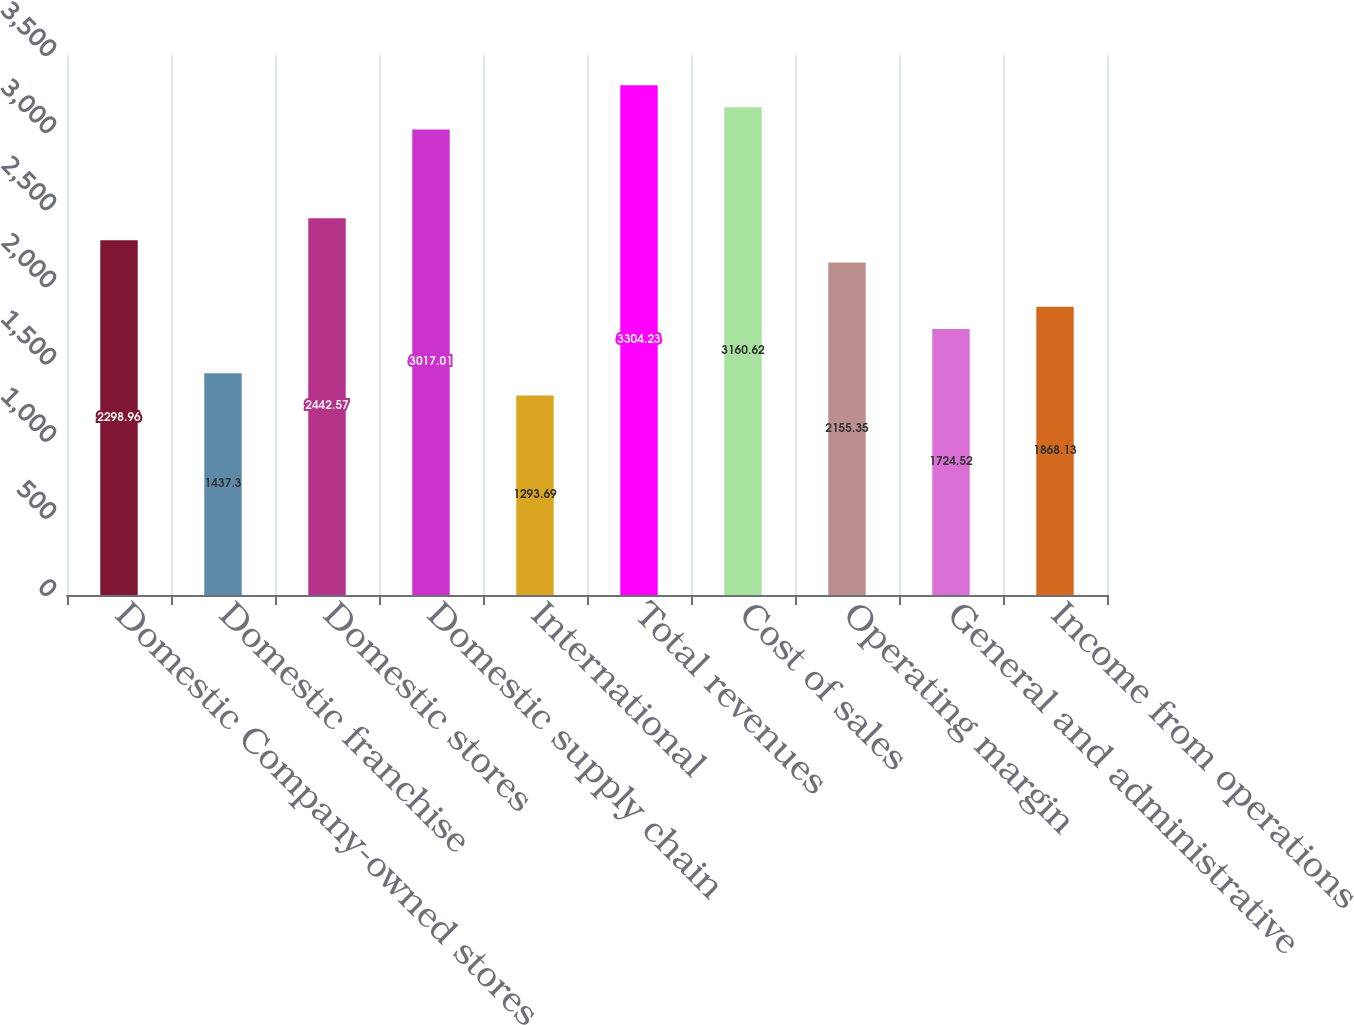<chart> <loc_0><loc_0><loc_500><loc_500><bar_chart><fcel>Domestic Company-owned stores<fcel>Domestic franchise<fcel>Domestic stores<fcel>Domestic supply chain<fcel>International<fcel>Total revenues<fcel>Cost of sales<fcel>Operating margin<fcel>General and administrative<fcel>Income from operations<nl><fcel>2298.96<fcel>1437.3<fcel>2442.57<fcel>3017.01<fcel>1293.69<fcel>3304.23<fcel>3160.62<fcel>2155.35<fcel>1724.52<fcel>1868.13<nl></chart> 